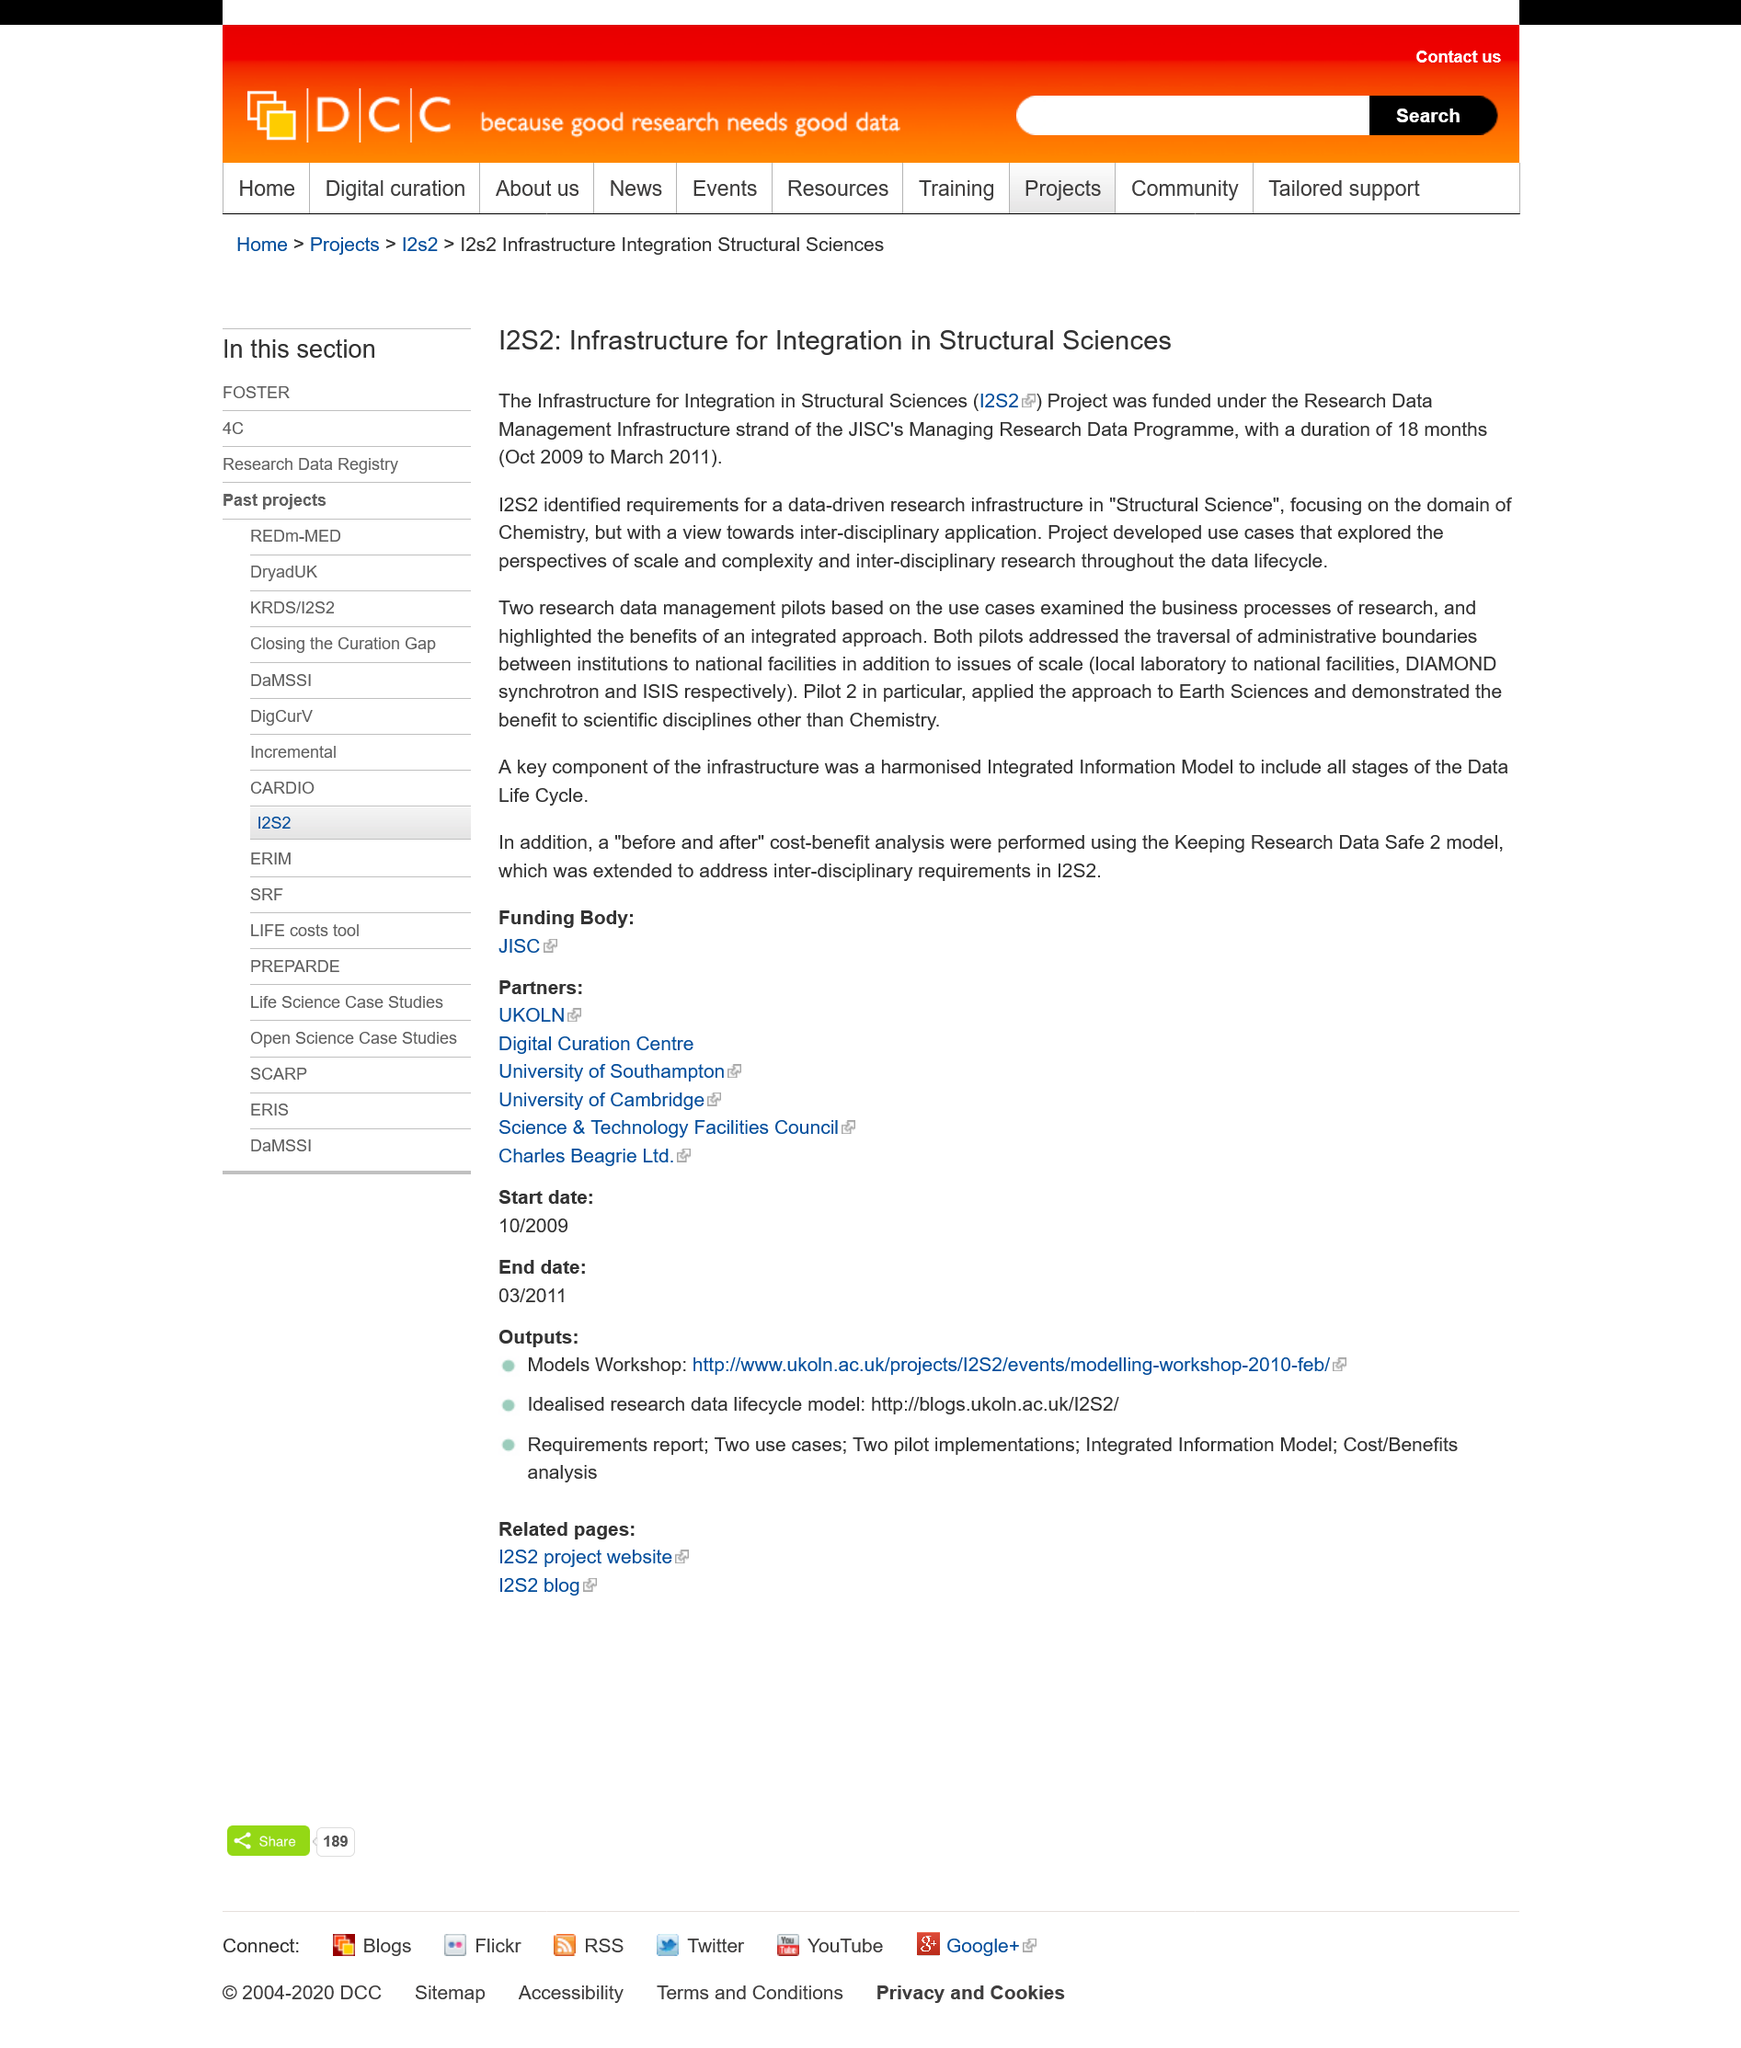Give some essential details in this illustration. A total of two data management pilots were researched under the Infrastructure for Integration in Structural Sciences (I2S2) program. For 18 months, from October 2009 to March 2011, the Infrastructure for Integration received funding. The Infrastructure for Integration in Structural Sciences Project focuses on two scientific fields: Chemistry and Earth Sciences, in order to advance understanding and improve technologies related to structures and materials. 